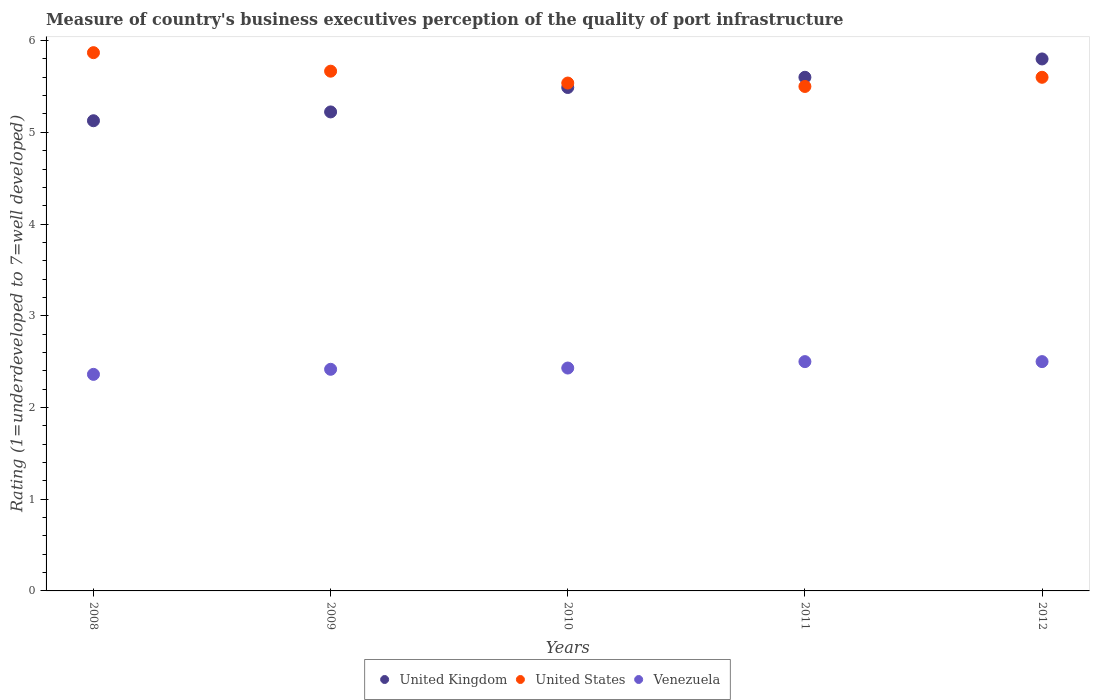How many different coloured dotlines are there?
Make the answer very short. 3. Is the number of dotlines equal to the number of legend labels?
Provide a short and direct response. Yes. What is the ratings of the quality of port infrastructure in Venezuela in 2009?
Your answer should be compact. 2.42. Across all years, what is the maximum ratings of the quality of port infrastructure in Venezuela?
Give a very brief answer. 2.5. Across all years, what is the minimum ratings of the quality of port infrastructure in United States?
Provide a short and direct response. 5.5. In which year was the ratings of the quality of port infrastructure in United Kingdom minimum?
Your answer should be very brief. 2008. What is the total ratings of the quality of port infrastructure in United States in the graph?
Your answer should be very brief. 28.17. What is the difference between the ratings of the quality of port infrastructure in United States in 2008 and that in 2009?
Make the answer very short. 0.2. What is the difference between the ratings of the quality of port infrastructure in Venezuela in 2011 and the ratings of the quality of port infrastructure in United States in 2010?
Your response must be concise. -3.04. What is the average ratings of the quality of port infrastructure in United Kingdom per year?
Your answer should be compact. 5.45. In how many years, is the ratings of the quality of port infrastructure in United States greater than 1.2?
Your answer should be compact. 5. What is the ratio of the ratings of the quality of port infrastructure in United Kingdom in 2008 to that in 2012?
Provide a short and direct response. 0.88. Is the ratings of the quality of port infrastructure in United States in 2008 less than that in 2009?
Offer a very short reply. No. Is the difference between the ratings of the quality of port infrastructure in United States in 2008 and 2009 greater than the difference between the ratings of the quality of port infrastructure in Venezuela in 2008 and 2009?
Provide a short and direct response. Yes. What is the difference between the highest and the lowest ratings of the quality of port infrastructure in United Kingdom?
Make the answer very short. 0.67. Is it the case that in every year, the sum of the ratings of the quality of port infrastructure in United Kingdom and ratings of the quality of port infrastructure in United States  is greater than the ratings of the quality of port infrastructure in Venezuela?
Your answer should be very brief. Yes. Is the ratings of the quality of port infrastructure in Venezuela strictly less than the ratings of the quality of port infrastructure in United Kingdom over the years?
Your answer should be compact. Yes. How many years are there in the graph?
Your response must be concise. 5. What is the difference between two consecutive major ticks on the Y-axis?
Your response must be concise. 1. Are the values on the major ticks of Y-axis written in scientific E-notation?
Keep it short and to the point. No. Where does the legend appear in the graph?
Ensure brevity in your answer.  Bottom center. How many legend labels are there?
Provide a short and direct response. 3. What is the title of the graph?
Offer a terse response. Measure of country's business executives perception of the quality of port infrastructure. What is the label or title of the X-axis?
Your answer should be very brief. Years. What is the label or title of the Y-axis?
Your response must be concise. Rating (1=underdeveloped to 7=well developed). What is the Rating (1=underdeveloped to 7=well developed) of United Kingdom in 2008?
Your response must be concise. 5.13. What is the Rating (1=underdeveloped to 7=well developed) in United States in 2008?
Offer a very short reply. 5.87. What is the Rating (1=underdeveloped to 7=well developed) of Venezuela in 2008?
Give a very brief answer. 2.36. What is the Rating (1=underdeveloped to 7=well developed) in United Kingdom in 2009?
Offer a very short reply. 5.22. What is the Rating (1=underdeveloped to 7=well developed) of United States in 2009?
Ensure brevity in your answer.  5.67. What is the Rating (1=underdeveloped to 7=well developed) of Venezuela in 2009?
Your answer should be compact. 2.42. What is the Rating (1=underdeveloped to 7=well developed) of United Kingdom in 2010?
Offer a terse response. 5.49. What is the Rating (1=underdeveloped to 7=well developed) in United States in 2010?
Give a very brief answer. 5.54. What is the Rating (1=underdeveloped to 7=well developed) in Venezuela in 2010?
Keep it short and to the point. 2.43. What is the Rating (1=underdeveloped to 7=well developed) of United States in 2011?
Ensure brevity in your answer.  5.5. What is the Rating (1=underdeveloped to 7=well developed) of Venezuela in 2011?
Your answer should be compact. 2.5. What is the Rating (1=underdeveloped to 7=well developed) in United Kingdom in 2012?
Provide a short and direct response. 5.8. What is the Rating (1=underdeveloped to 7=well developed) in Venezuela in 2012?
Make the answer very short. 2.5. Across all years, what is the maximum Rating (1=underdeveloped to 7=well developed) in United States?
Keep it short and to the point. 5.87. Across all years, what is the minimum Rating (1=underdeveloped to 7=well developed) of United Kingdom?
Keep it short and to the point. 5.13. Across all years, what is the minimum Rating (1=underdeveloped to 7=well developed) in Venezuela?
Make the answer very short. 2.36. What is the total Rating (1=underdeveloped to 7=well developed) in United Kingdom in the graph?
Offer a very short reply. 27.24. What is the total Rating (1=underdeveloped to 7=well developed) of United States in the graph?
Your answer should be very brief. 28.17. What is the total Rating (1=underdeveloped to 7=well developed) in Venezuela in the graph?
Give a very brief answer. 12.21. What is the difference between the Rating (1=underdeveloped to 7=well developed) in United Kingdom in 2008 and that in 2009?
Give a very brief answer. -0.1. What is the difference between the Rating (1=underdeveloped to 7=well developed) of United States in 2008 and that in 2009?
Your response must be concise. 0.2. What is the difference between the Rating (1=underdeveloped to 7=well developed) in Venezuela in 2008 and that in 2009?
Your response must be concise. -0.06. What is the difference between the Rating (1=underdeveloped to 7=well developed) of United Kingdom in 2008 and that in 2010?
Make the answer very short. -0.36. What is the difference between the Rating (1=underdeveloped to 7=well developed) in United States in 2008 and that in 2010?
Your response must be concise. 0.33. What is the difference between the Rating (1=underdeveloped to 7=well developed) in Venezuela in 2008 and that in 2010?
Your answer should be very brief. -0.07. What is the difference between the Rating (1=underdeveloped to 7=well developed) in United Kingdom in 2008 and that in 2011?
Ensure brevity in your answer.  -0.47. What is the difference between the Rating (1=underdeveloped to 7=well developed) in United States in 2008 and that in 2011?
Ensure brevity in your answer.  0.37. What is the difference between the Rating (1=underdeveloped to 7=well developed) in Venezuela in 2008 and that in 2011?
Ensure brevity in your answer.  -0.14. What is the difference between the Rating (1=underdeveloped to 7=well developed) of United Kingdom in 2008 and that in 2012?
Make the answer very short. -0.67. What is the difference between the Rating (1=underdeveloped to 7=well developed) in United States in 2008 and that in 2012?
Your answer should be very brief. 0.27. What is the difference between the Rating (1=underdeveloped to 7=well developed) in Venezuela in 2008 and that in 2012?
Provide a short and direct response. -0.14. What is the difference between the Rating (1=underdeveloped to 7=well developed) of United Kingdom in 2009 and that in 2010?
Provide a succinct answer. -0.27. What is the difference between the Rating (1=underdeveloped to 7=well developed) in United States in 2009 and that in 2010?
Your answer should be very brief. 0.13. What is the difference between the Rating (1=underdeveloped to 7=well developed) in Venezuela in 2009 and that in 2010?
Your answer should be very brief. -0.01. What is the difference between the Rating (1=underdeveloped to 7=well developed) of United Kingdom in 2009 and that in 2011?
Provide a succinct answer. -0.38. What is the difference between the Rating (1=underdeveloped to 7=well developed) in United States in 2009 and that in 2011?
Offer a terse response. 0.17. What is the difference between the Rating (1=underdeveloped to 7=well developed) in Venezuela in 2009 and that in 2011?
Give a very brief answer. -0.08. What is the difference between the Rating (1=underdeveloped to 7=well developed) in United Kingdom in 2009 and that in 2012?
Provide a succinct answer. -0.58. What is the difference between the Rating (1=underdeveloped to 7=well developed) of United States in 2009 and that in 2012?
Provide a succinct answer. 0.07. What is the difference between the Rating (1=underdeveloped to 7=well developed) of Venezuela in 2009 and that in 2012?
Give a very brief answer. -0.08. What is the difference between the Rating (1=underdeveloped to 7=well developed) of United Kingdom in 2010 and that in 2011?
Ensure brevity in your answer.  -0.11. What is the difference between the Rating (1=underdeveloped to 7=well developed) in United States in 2010 and that in 2011?
Provide a short and direct response. 0.04. What is the difference between the Rating (1=underdeveloped to 7=well developed) in Venezuela in 2010 and that in 2011?
Offer a very short reply. -0.07. What is the difference between the Rating (1=underdeveloped to 7=well developed) in United Kingdom in 2010 and that in 2012?
Make the answer very short. -0.31. What is the difference between the Rating (1=underdeveloped to 7=well developed) of United States in 2010 and that in 2012?
Your answer should be compact. -0.06. What is the difference between the Rating (1=underdeveloped to 7=well developed) in Venezuela in 2010 and that in 2012?
Provide a succinct answer. -0.07. What is the difference between the Rating (1=underdeveloped to 7=well developed) in United Kingdom in 2008 and the Rating (1=underdeveloped to 7=well developed) in United States in 2009?
Offer a very short reply. -0.54. What is the difference between the Rating (1=underdeveloped to 7=well developed) of United Kingdom in 2008 and the Rating (1=underdeveloped to 7=well developed) of Venezuela in 2009?
Your answer should be very brief. 2.71. What is the difference between the Rating (1=underdeveloped to 7=well developed) of United States in 2008 and the Rating (1=underdeveloped to 7=well developed) of Venezuela in 2009?
Offer a terse response. 3.45. What is the difference between the Rating (1=underdeveloped to 7=well developed) in United Kingdom in 2008 and the Rating (1=underdeveloped to 7=well developed) in United States in 2010?
Provide a short and direct response. -0.41. What is the difference between the Rating (1=underdeveloped to 7=well developed) in United Kingdom in 2008 and the Rating (1=underdeveloped to 7=well developed) in Venezuela in 2010?
Make the answer very short. 2.7. What is the difference between the Rating (1=underdeveloped to 7=well developed) of United States in 2008 and the Rating (1=underdeveloped to 7=well developed) of Venezuela in 2010?
Provide a succinct answer. 3.44. What is the difference between the Rating (1=underdeveloped to 7=well developed) in United Kingdom in 2008 and the Rating (1=underdeveloped to 7=well developed) in United States in 2011?
Make the answer very short. -0.37. What is the difference between the Rating (1=underdeveloped to 7=well developed) of United Kingdom in 2008 and the Rating (1=underdeveloped to 7=well developed) of Venezuela in 2011?
Offer a terse response. 2.63. What is the difference between the Rating (1=underdeveloped to 7=well developed) of United States in 2008 and the Rating (1=underdeveloped to 7=well developed) of Venezuela in 2011?
Your answer should be compact. 3.37. What is the difference between the Rating (1=underdeveloped to 7=well developed) in United Kingdom in 2008 and the Rating (1=underdeveloped to 7=well developed) in United States in 2012?
Your answer should be very brief. -0.47. What is the difference between the Rating (1=underdeveloped to 7=well developed) in United Kingdom in 2008 and the Rating (1=underdeveloped to 7=well developed) in Venezuela in 2012?
Ensure brevity in your answer.  2.63. What is the difference between the Rating (1=underdeveloped to 7=well developed) in United States in 2008 and the Rating (1=underdeveloped to 7=well developed) in Venezuela in 2012?
Your answer should be very brief. 3.37. What is the difference between the Rating (1=underdeveloped to 7=well developed) of United Kingdom in 2009 and the Rating (1=underdeveloped to 7=well developed) of United States in 2010?
Offer a very short reply. -0.31. What is the difference between the Rating (1=underdeveloped to 7=well developed) of United Kingdom in 2009 and the Rating (1=underdeveloped to 7=well developed) of Venezuela in 2010?
Your answer should be compact. 2.79. What is the difference between the Rating (1=underdeveloped to 7=well developed) of United States in 2009 and the Rating (1=underdeveloped to 7=well developed) of Venezuela in 2010?
Provide a short and direct response. 3.24. What is the difference between the Rating (1=underdeveloped to 7=well developed) of United Kingdom in 2009 and the Rating (1=underdeveloped to 7=well developed) of United States in 2011?
Ensure brevity in your answer.  -0.28. What is the difference between the Rating (1=underdeveloped to 7=well developed) in United Kingdom in 2009 and the Rating (1=underdeveloped to 7=well developed) in Venezuela in 2011?
Give a very brief answer. 2.72. What is the difference between the Rating (1=underdeveloped to 7=well developed) in United States in 2009 and the Rating (1=underdeveloped to 7=well developed) in Venezuela in 2011?
Provide a short and direct response. 3.17. What is the difference between the Rating (1=underdeveloped to 7=well developed) in United Kingdom in 2009 and the Rating (1=underdeveloped to 7=well developed) in United States in 2012?
Ensure brevity in your answer.  -0.38. What is the difference between the Rating (1=underdeveloped to 7=well developed) of United Kingdom in 2009 and the Rating (1=underdeveloped to 7=well developed) of Venezuela in 2012?
Provide a succinct answer. 2.72. What is the difference between the Rating (1=underdeveloped to 7=well developed) of United States in 2009 and the Rating (1=underdeveloped to 7=well developed) of Venezuela in 2012?
Ensure brevity in your answer.  3.17. What is the difference between the Rating (1=underdeveloped to 7=well developed) of United Kingdom in 2010 and the Rating (1=underdeveloped to 7=well developed) of United States in 2011?
Make the answer very short. -0.01. What is the difference between the Rating (1=underdeveloped to 7=well developed) of United Kingdom in 2010 and the Rating (1=underdeveloped to 7=well developed) of Venezuela in 2011?
Ensure brevity in your answer.  2.99. What is the difference between the Rating (1=underdeveloped to 7=well developed) of United States in 2010 and the Rating (1=underdeveloped to 7=well developed) of Venezuela in 2011?
Offer a very short reply. 3.04. What is the difference between the Rating (1=underdeveloped to 7=well developed) of United Kingdom in 2010 and the Rating (1=underdeveloped to 7=well developed) of United States in 2012?
Offer a terse response. -0.11. What is the difference between the Rating (1=underdeveloped to 7=well developed) of United Kingdom in 2010 and the Rating (1=underdeveloped to 7=well developed) of Venezuela in 2012?
Provide a short and direct response. 2.99. What is the difference between the Rating (1=underdeveloped to 7=well developed) of United States in 2010 and the Rating (1=underdeveloped to 7=well developed) of Venezuela in 2012?
Offer a terse response. 3.04. What is the difference between the Rating (1=underdeveloped to 7=well developed) of United Kingdom in 2011 and the Rating (1=underdeveloped to 7=well developed) of United States in 2012?
Your response must be concise. 0. What is the average Rating (1=underdeveloped to 7=well developed) in United Kingdom per year?
Make the answer very short. 5.45. What is the average Rating (1=underdeveloped to 7=well developed) in United States per year?
Offer a terse response. 5.63. What is the average Rating (1=underdeveloped to 7=well developed) of Venezuela per year?
Provide a succinct answer. 2.44. In the year 2008, what is the difference between the Rating (1=underdeveloped to 7=well developed) of United Kingdom and Rating (1=underdeveloped to 7=well developed) of United States?
Provide a succinct answer. -0.74. In the year 2008, what is the difference between the Rating (1=underdeveloped to 7=well developed) of United Kingdom and Rating (1=underdeveloped to 7=well developed) of Venezuela?
Keep it short and to the point. 2.77. In the year 2008, what is the difference between the Rating (1=underdeveloped to 7=well developed) in United States and Rating (1=underdeveloped to 7=well developed) in Venezuela?
Make the answer very short. 3.51. In the year 2009, what is the difference between the Rating (1=underdeveloped to 7=well developed) of United Kingdom and Rating (1=underdeveloped to 7=well developed) of United States?
Make the answer very short. -0.44. In the year 2009, what is the difference between the Rating (1=underdeveloped to 7=well developed) of United Kingdom and Rating (1=underdeveloped to 7=well developed) of Venezuela?
Your answer should be compact. 2.81. In the year 2009, what is the difference between the Rating (1=underdeveloped to 7=well developed) of United States and Rating (1=underdeveloped to 7=well developed) of Venezuela?
Ensure brevity in your answer.  3.25. In the year 2010, what is the difference between the Rating (1=underdeveloped to 7=well developed) in United Kingdom and Rating (1=underdeveloped to 7=well developed) in United States?
Offer a terse response. -0.05. In the year 2010, what is the difference between the Rating (1=underdeveloped to 7=well developed) in United Kingdom and Rating (1=underdeveloped to 7=well developed) in Venezuela?
Give a very brief answer. 3.06. In the year 2010, what is the difference between the Rating (1=underdeveloped to 7=well developed) in United States and Rating (1=underdeveloped to 7=well developed) in Venezuela?
Keep it short and to the point. 3.11. In the year 2011, what is the difference between the Rating (1=underdeveloped to 7=well developed) in United Kingdom and Rating (1=underdeveloped to 7=well developed) in United States?
Keep it short and to the point. 0.1. In the year 2011, what is the difference between the Rating (1=underdeveloped to 7=well developed) of United Kingdom and Rating (1=underdeveloped to 7=well developed) of Venezuela?
Offer a terse response. 3.1. In the year 2011, what is the difference between the Rating (1=underdeveloped to 7=well developed) in United States and Rating (1=underdeveloped to 7=well developed) in Venezuela?
Provide a short and direct response. 3. In the year 2012, what is the difference between the Rating (1=underdeveloped to 7=well developed) in United Kingdom and Rating (1=underdeveloped to 7=well developed) in United States?
Give a very brief answer. 0.2. In the year 2012, what is the difference between the Rating (1=underdeveloped to 7=well developed) of United Kingdom and Rating (1=underdeveloped to 7=well developed) of Venezuela?
Ensure brevity in your answer.  3.3. In the year 2012, what is the difference between the Rating (1=underdeveloped to 7=well developed) of United States and Rating (1=underdeveloped to 7=well developed) of Venezuela?
Offer a terse response. 3.1. What is the ratio of the Rating (1=underdeveloped to 7=well developed) in United Kingdom in 2008 to that in 2009?
Make the answer very short. 0.98. What is the ratio of the Rating (1=underdeveloped to 7=well developed) in United States in 2008 to that in 2009?
Make the answer very short. 1.04. What is the ratio of the Rating (1=underdeveloped to 7=well developed) of Venezuela in 2008 to that in 2009?
Offer a very short reply. 0.98. What is the ratio of the Rating (1=underdeveloped to 7=well developed) of United Kingdom in 2008 to that in 2010?
Provide a short and direct response. 0.93. What is the ratio of the Rating (1=underdeveloped to 7=well developed) in United States in 2008 to that in 2010?
Provide a short and direct response. 1.06. What is the ratio of the Rating (1=underdeveloped to 7=well developed) in Venezuela in 2008 to that in 2010?
Offer a terse response. 0.97. What is the ratio of the Rating (1=underdeveloped to 7=well developed) in United Kingdom in 2008 to that in 2011?
Your answer should be very brief. 0.92. What is the ratio of the Rating (1=underdeveloped to 7=well developed) in United States in 2008 to that in 2011?
Ensure brevity in your answer.  1.07. What is the ratio of the Rating (1=underdeveloped to 7=well developed) in Venezuela in 2008 to that in 2011?
Your response must be concise. 0.94. What is the ratio of the Rating (1=underdeveloped to 7=well developed) of United Kingdom in 2008 to that in 2012?
Provide a short and direct response. 0.88. What is the ratio of the Rating (1=underdeveloped to 7=well developed) in United States in 2008 to that in 2012?
Provide a short and direct response. 1.05. What is the ratio of the Rating (1=underdeveloped to 7=well developed) in Venezuela in 2008 to that in 2012?
Your answer should be very brief. 0.94. What is the ratio of the Rating (1=underdeveloped to 7=well developed) in United Kingdom in 2009 to that in 2010?
Ensure brevity in your answer.  0.95. What is the ratio of the Rating (1=underdeveloped to 7=well developed) of United States in 2009 to that in 2010?
Ensure brevity in your answer.  1.02. What is the ratio of the Rating (1=underdeveloped to 7=well developed) in Venezuela in 2009 to that in 2010?
Your response must be concise. 0.99. What is the ratio of the Rating (1=underdeveloped to 7=well developed) in United Kingdom in 2009 to that in 2011?
Your answer should be compact. 0.93. What is the ratio of the Rating (1=underdeveloped to 7=well developed) in United States in 2009 to that in 2011?
Provide a succinct answer. 1.03. What is the ratio of the Rating (1=underdeveloped to 7=well developed) of Venezuela in 2009 to that in 2011?
Provide a succinct answer. 0.97. What is the ratio of the Rating (1=underdeveloped to 7=well developed) in United Kingdom in 2009 to that in 2012?
Offer a terse response. 0.9. What is the ratio of the Rating (1=underdeveloped to 7=well developed) in United States in 2009 to that in 2012?
Offer a terse response. 1.01. What is the ratio of the Rating (1=underdeveloped to 7=well developed) of Venezuela in 2009 to that in 2012?
Ensure brevity in your answer.  0.97. What is the ratio of the Rating (1=underdeveloped to 7=well developed) of United Kingdom in 2010 to that in 2011?
Give a very brief answer. 0.98. What is the ratio of the Rating (1=underdeveloped to 7=well developed) in United States in 2010 to that in 2011?
Offer a very short reply. 1.01. What is the ratio of the Rating (1=underdeveloped to 7=well developed) of Venezuela in 2010 to that in 2011?
Keep it short and to the point. 0.97. What is the ratio of the Rating (1=underdeveloped to 7=well developed) of United Kingdom in 2010 to that in 2012?
Your response must be concise. 0.95. What is the ratio of the Rating (1=underdeveloped to 7=well developed) of United States in 2010 to that in 2012?
Give a very brief answer. 0.99. What is the ratio of the Rating (1=underdeveloped to 7=well developed) in United Kingdom in 2011 to that in 2012?
Give a very brief answer. 0.97. What is the ratio of the Rating (1=underdeveloped to 7=well developed) of United States in 2011 to that in 2012?
Offer a terse response. 0.98. What is the ratio of the Rating (1=underdeveloped to 7=well developed) of Venezuela in 2011 to that in 2012?
Offer a very short reply. 1. What is the difference between the highest and the second highest Rating (1=underdeveloped to 7=well developed) of United Kingdom?
Give a very brief answer. 0.2. What is the difference between the highest and the second highest Rating (1=underdeveloped to 7=well developed) of United States?
Your response must be concise. 0.2. What is the difference between the highest and the second highest Rating (1=underdeveloped to 7=well developed) of Venezuela?
Make the answer very short. 0. What is the difference between the highest and the lowest Rating (1=underdeveloped to 7=well developed) in United Kingdom?
Keep it short and to the point. 0.67. What is the difference between the highest and the lowest Rating (1=underdeveloped to 7=well developed) in United States?
Give a very brief answer. 0.37. What is the difference between the highest and the lowest Rating (1=underdeveloped to 7=well developed) in Venezuela?
Your answer should be very brief. 0.14. 